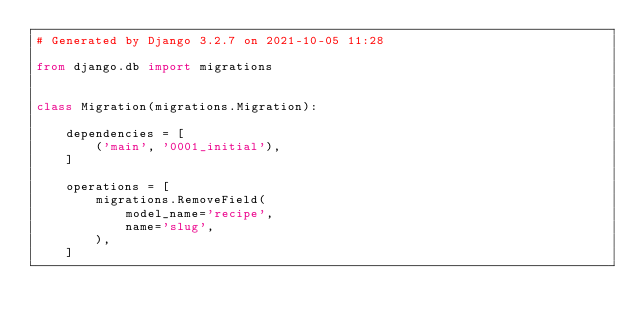Convert code to text. <code><loc_0><loc_0><loc_500><loc_500><_Python_># Generated by Django 3.2.7 on 2021-10-05 11:28

from django.db import migrations


class Migration(migrations.Migration):

    dependencies = [
        ('main', '0001_initial'),
    ]

    operations = [
        migrations.RemoveField(
            model_name='recipe',
            name='slug',
        ),
    ]
</code> 